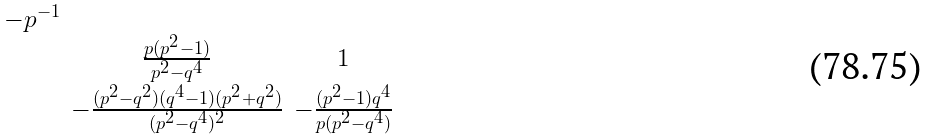Convert formula to latex. <formula><loc_0><loc_0><loc_500><loc_500>\begin{smallmatrix} - p ^ { - 1 } & & \\ & \frac { p ( p ^ { 2 } - 1 ) } { p ^ { 2 } - q ^ { 4 } } & 1 \\ & - \frac { ( p ^ { 2 } - q ^ { 2 } ) ( q ^ { 4 } - 1 ) ( p ^ { 2 } + q ^ { 2 } ) } { ( p ^ { 2 } - q ^ { 4 } ) ^ { 2 } } & - \frac { ( p ^ { 2 } - 1 ) q ^ { 4 } } { p ( p ^ { 2 } - q ^ { 4 } ) } \end{smallmatrix}</formula> 